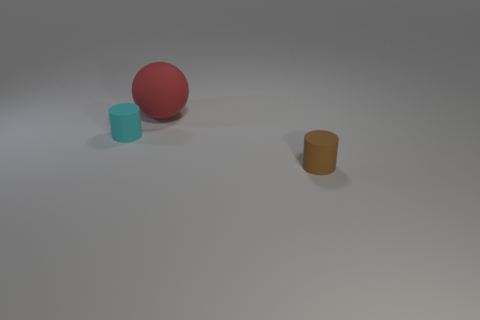There is a object that is to the right of the cyan cylinder and in front of the big matte sphere; what material is it made of?
Ensure brevity in your answer.  Rubber. There is a large red thing that is the same material as the small cyan thing; what is its shape?
Keep it short and to the point. Sphere. There is a cyan cylinder that is made of the same material as the tiny brown cylinder; what is its size?
Make the answer very short. Small. What is the shape of the matte thing that is both left of the brown object and in front of the large ball?
Your response must be concise. Cylinder. There is a matte object behind the rubber thing that is on the left side of the large red object; what size is it?
Provide a succinct answer. Large. What is the material of the tiny cyan cylinder?
Ensure brevity in your answer.  Rubber. Are any small blue metallic blocks visible?
Provide a succinct answer. No. Is the number of tiny brown rubber objects that are in front of the brown cylinder the same as the number of blue balls?
Offer a very short reply. Yes. How many small objects are either brown matte things or red cubes?
Offer a terse response. 1. What number of cyan things are the same shape as the small brown object?
Ensure brevity in your answer.  1. 